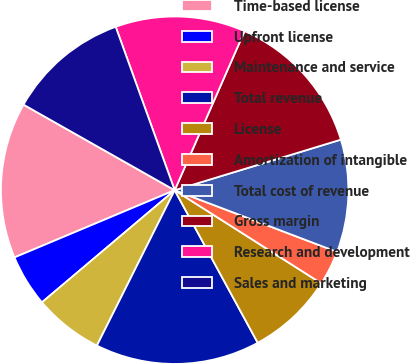Convert chart. <chart><loc_0><loc_0><loc_500><loc_500><pie_chart><fcel>Time-based license<fcel>Upfront license<fcel>Maintenance and service<fcel>Total revenue<fcel>License<fcel>Amortization of intangible<fcel>Total cost of revenue<fcel>Gross margin<fcel>Research and development<fcel>Sales and marketing<nl><fcel>14.52%<fcel>4.84%<fcel>6.45%<fcel>15.32%<fcel>8.06%<fcel>3.23%<fcel>10.48%<fcel>13.71%<fcel>12.1%<fcel>11.29%<nl></chart> 